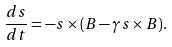Convert formula to latex. <formula><loc_0><loc_0><loc_500><loc_500>\frac { d { s } } { d t } = - { s } \times ( { B } - \gamma { s } \times { B } ) .</formula> 